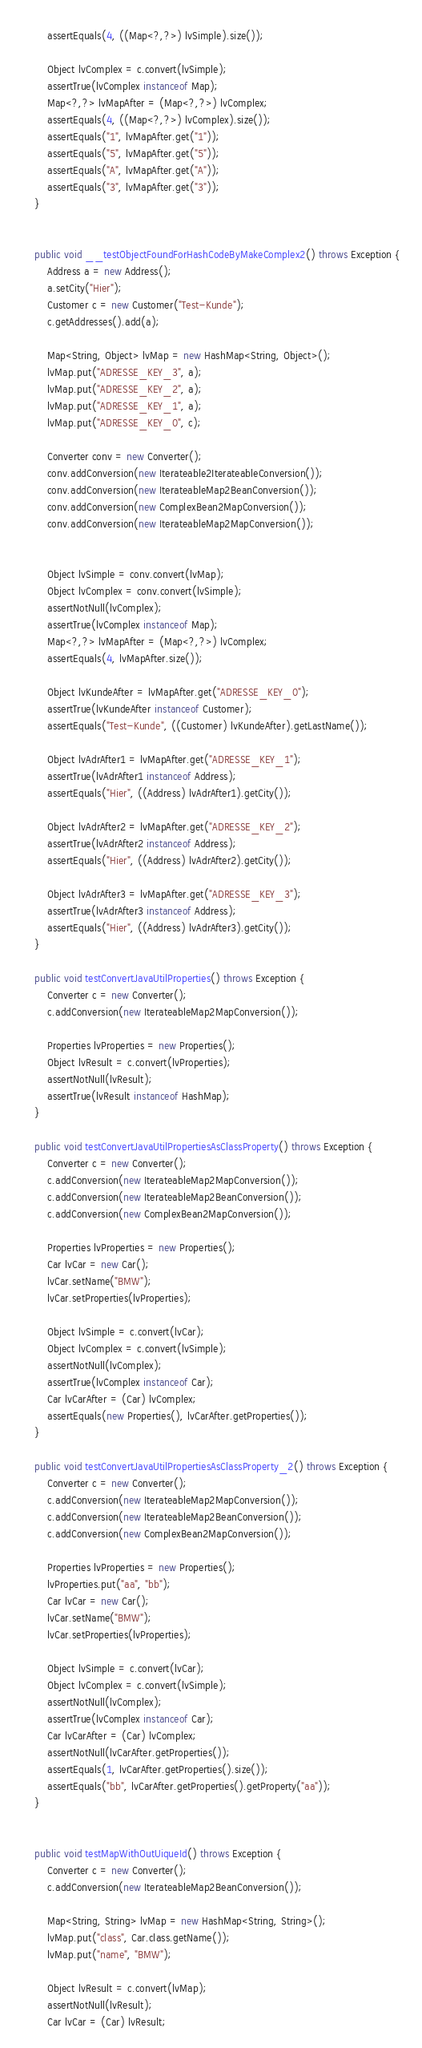Convert code to text. <code><loc_0><loc_0><loc_500><loc_500><_Java_>		assertEquals(4, ((Map<?,?>) lvSimple).size());
		
		Object lvComplex = c.convert(lvSimple);
		assertTrue(lvComplex instanceof Map);
		Map<?,?> lvMapAfter = (Map<?,?>) lvComplex;
		assertEquals(4, ((Map<?,?>) lvComplex).size());
		assertEquals("1", lvMapAfter.get("1"));
		assertEquals("5", lvMapAfter.get("5"));
		assertEquals("A", lvMapAfter.get("A"));
		assertEquals("3", lvMapAfter.get("3"));
	}
	

	public void __testObjectFoundForHashCodeByMakeComplex2() throws Exception {
		Address a = new Address();
		a.setCity("Hier");
		Customer c = new Customer("Test-Kunde");
		c.getAddresses().add(a);

		Map<String, Object> lvMap = new HashMap<String, Object>();
		lvMap.put("ADRESSE_KEY_3", a);
		lvMap.put("ADRESSE_KEY_2", a);
		lvMap.put("ADRESSE_KEY_1", a);
		lvMap.put("ADRESSE_KEY_0", c);

		Converter conv = new Converter();
		conv.addConversion(new Iterateable2IterateableConversion());
		conv.addConversion(new IterateableMap2BeanConversion());
		conv.addConversion(new ComplexBean2MapConversion());
		conv.addConversion(new IterateableMap2MapConversion());
		
		
		Object lvSimple = conv.convert(lvMap);
		Object lvComplex = conv.convert(lvSimple);
		assertNotNull(lvComplex);
		assertTrue(lvComplex instanceof Map);
		Map<?,?> lvMapAfter = (Map<?,?>) lvComplex;
		assertEquals(4, lvMapAfter.size());

		Object lvKundeAfter = lvMapAfter.get("ADRESSE_KEY_0");
		assertTrue(lvKundeAfter instanceof Customer);
		assertEquals("Test-Kunde", ((Customer) lvKundeAfter).getLastName());

		Object lvAdrAfter1 = lvMapAfter.get("ADRESSE_KEY_1");
		assertTrue(lvAdrAfter1 instanceof Address);
		assertEquals("Hier", ((Address) lvAdrAfter1).getCity());
		
		Object lvAdrAfter2 = lvMapAfter.get("ADRESSE_KEY_2");
		assertTrue(lvAdrAfter2 instanceof Address);
		assertEquals("Hier", ((Address) lvAdrAfter2).getCity());

		Object lvAdrAfter3 = lvMapAfter.get("ADRESSE_KEY_3");
		assertTrue(lvAdrAfter3 instanceof Address);
		assertEquals("Hier", ((Address) lvAdrAfter3).getCity());
	}

	public void testConvertJavaUtilProperties() throws Exception {
		Converter c = new Converter();
		c.addConversion(new IterateableMap2MapConversion());
		
		Properties lvProperties = new Properties();
		Object lvResult = c.convert(lvProperties);
		assertNotNull(lvResult);
		assertTrue(lvResult instanceof HashMap);
	}
	
	public void testConvertJavaUtilPropertiesAsClassProperty() throws Exception {
		Converter c = new Converter();
		c.addConversion(new IterateableMap2MapConversion());
		c.addConversion(new IterateableMap2BeanConversion());
		c.addConversion(new ComplexBean2MapConversion());
		
		Properties lvProperties = new Properties();
		Car lvCar = new Car();
		lvCar.setName("BMW");
		lvCar.setProperties(lvProperties);
		
		Object lvSimple = c.convert(lvCar);
		Object lvComplex = c.convert(lvSimple);
		assertNotNull(lvComplex);
		assertTrue(lvComplex instanceof Car);
		Car lvCarAfter = (Car) lvComplex;
		assertEquals(new Properties(), lvCarAfter.getProperties());
	}
	
	public void testConvertJavaUtilPropertiesAsClassProperty_2() throws Exception {
		Converter c = new Converter();
		c.addConversion(new IterateableMap2MapConversion());
		c.addConversion(new IterateableMap2BeanConversion());
		c.addConversion(new ComplexBean2MapConversion());
		
		Properties lvProperties = new Properties();
		lvProperties.put("aa", "bb");
		Car lvCar = new Car();
		lvCar.setName("BMW");
		lvCar.setProperties(lvProperties);
		
		Object lvSimple = c.convert(lvCar);
		Object lvComplex = c.convert(lvSimple);
		assertNotNull(lvComplex);
		assertTrue(lvComplex instanceof Car);
		Car lvCarAfter = (Car) lvComplex;
		assertNotNull(lvCarAfter.getProperties());
		assertEquals(1, lvCarAfter.getProperties().size());
		assertEquals("bb", lvCarAfter.getProperties().getProperty("aa"));
	}
	

	public void testMapWithOutUiqueId() throws Exception {
		Converter c = new Converter();
		c.addConversion(new IterateableMap2BeanConversion());

		Map<String, String> lvMap = new HashMap<String, String>();
		lvMap.put("class", Car.class.getName());
		lvMap.put("name", "BMW");			
		
		Object lvResult = c.convert(lvMap);
		assertNotNull(lvResult);
		Car lvCar = (Car) lvResult;</code> 